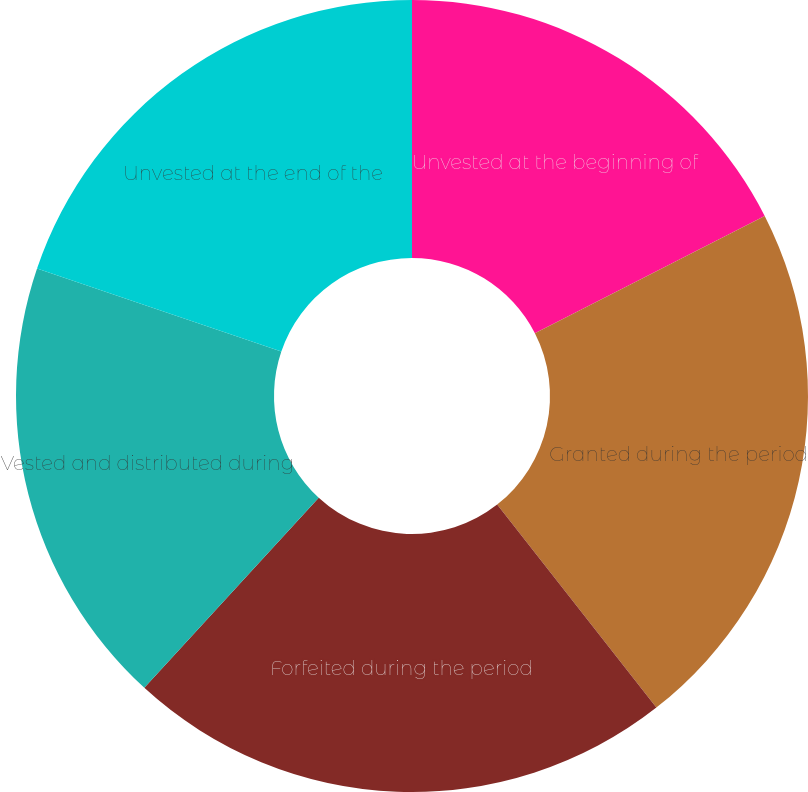<chart> <loc_0><loc_0><loc_500><loc_500><pie_chart><fcel>Unvested at the beginning of<fcel>Granted during the period<fcel>Forfeited during the period<fcel>Vested and distributed during<fcel>Unvested at the end of the<nl><fcel>17.49%<fcel>21.93%<fcel>22.4%<fcel>18.4%<fcel>19.79%<nl></chart> 